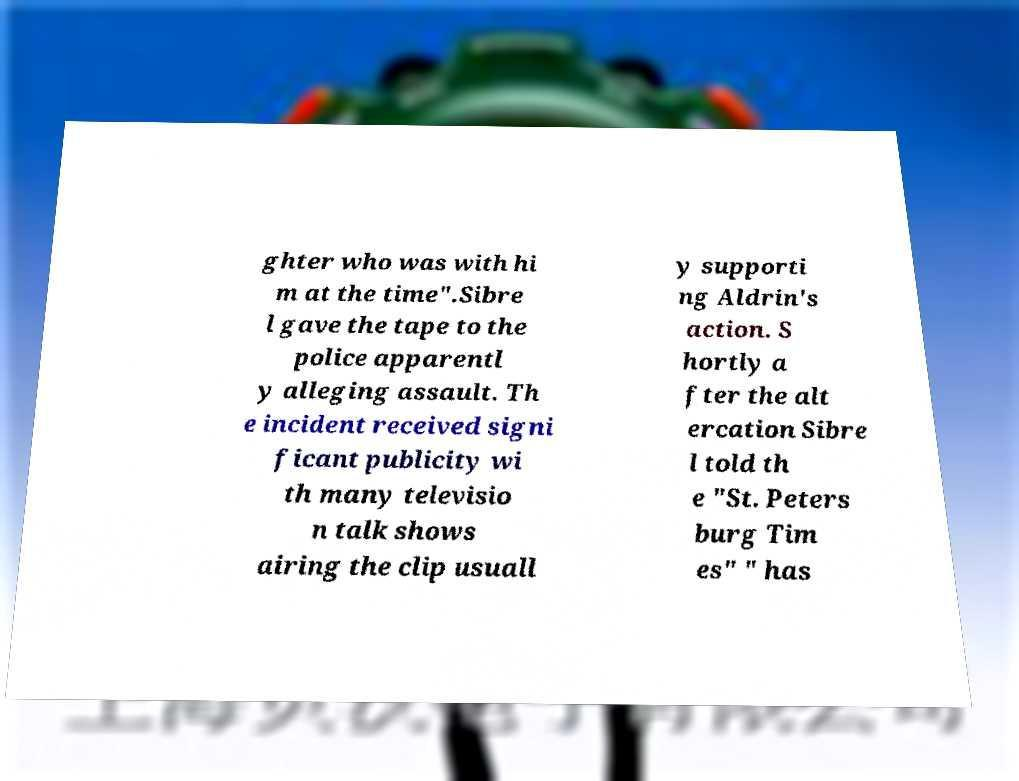Please identify and transcribe the text found in this image. ghter who was with hi m at the time".Sibre l gave the tape to the police apparentl y alleging assault. Th e incident received signi ficant publicity wi th many televisio n talk shows airing the clip usuall y supporti ng Aldrin's action. S hortly a fter the alt ercation Sibre l told th e "St. Peters burg Tim es" " has 